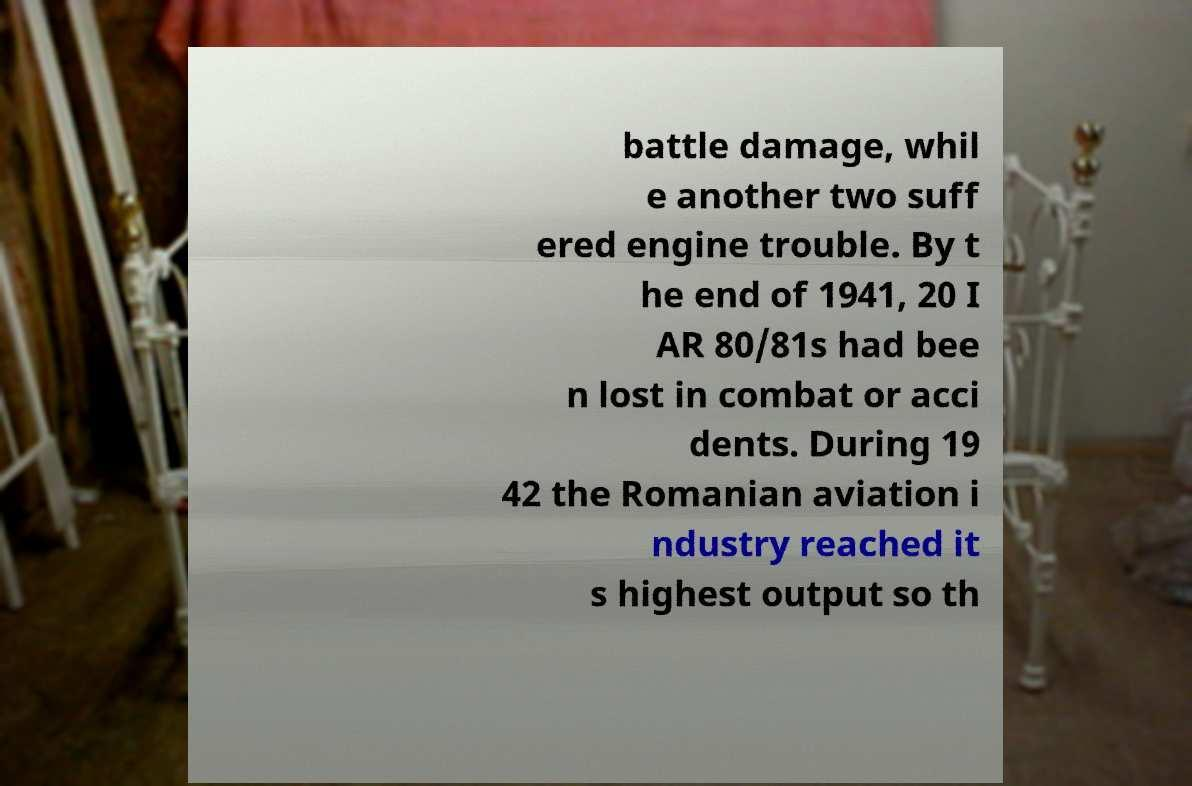Please read and relay the text visible in this image. What does it say? battle damage, whil e another two suff ered engine trouble. By t he end of 1941, 20 I AR 80/81s had bee n lost in combat or acci dents. During 19 42 the Romanian aviation i ndustry reached it s highest output so th 